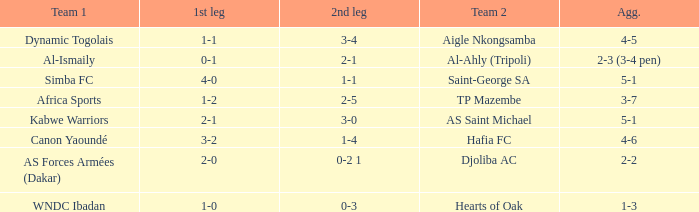What team played against Hafia FC (team 2)? Canon Yaoundé. I'm looking to parse the entire table for insights. Could you assist me with that? {'header': ['Team 1', '1st leg', '2nd leg', 'Team 2', 'Agg.'], 'rows': [['Dynamic Togolais', '1-1', '3-4', 'Aigle Nkongsamba', '4-5'], ['Al-Ismaily', '0-1', '2-1', 'Al-Ahly (Tripoli)', '2-3 (3-4 pen)'], ['Simba FC', '4-0', '1-1', 'Saint-George SA', '5-1'], ['Africa Sports', '1-2', '2-5', 'TP Mazembe', '3-7'], ['Kabwe Warriors', '2-1', '3-0', 'AS Saint Michael', '5-1'], ['Canon Yaoundé', '3-2', '1-4', 'Hafia FC', '4-6'], ['AS Forces Armées (Dakar)', '2-0', '0-2 1', 'Djoliba AC', '2-2'], ['WNDC Ibadan', '1-0', '0-3', 'Hearts of Oak', '1-3']]} 